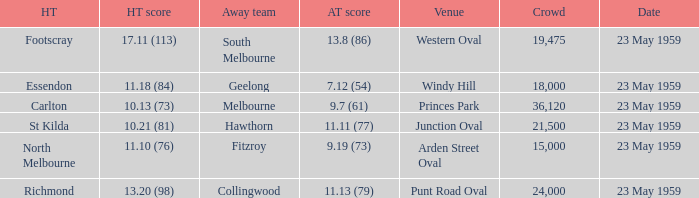What was the home team's score at the game held at Punt Road Oval? 13.20 (98). 